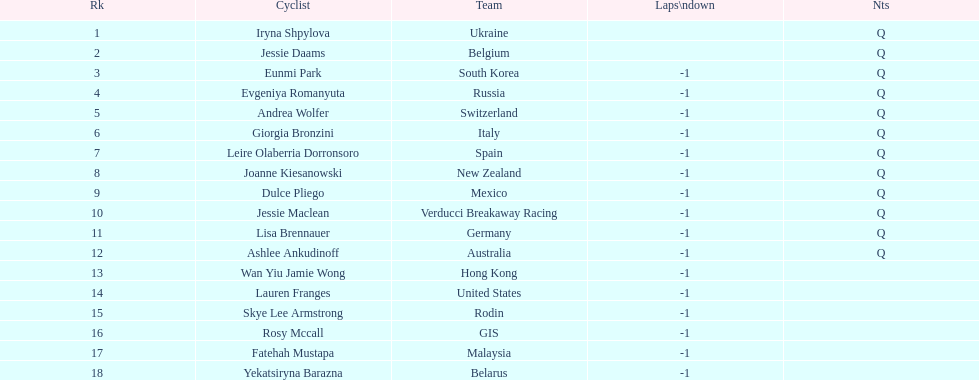What two cyclists come from teams with no laps down? Iryna Shpylova, Jessie Daams. 